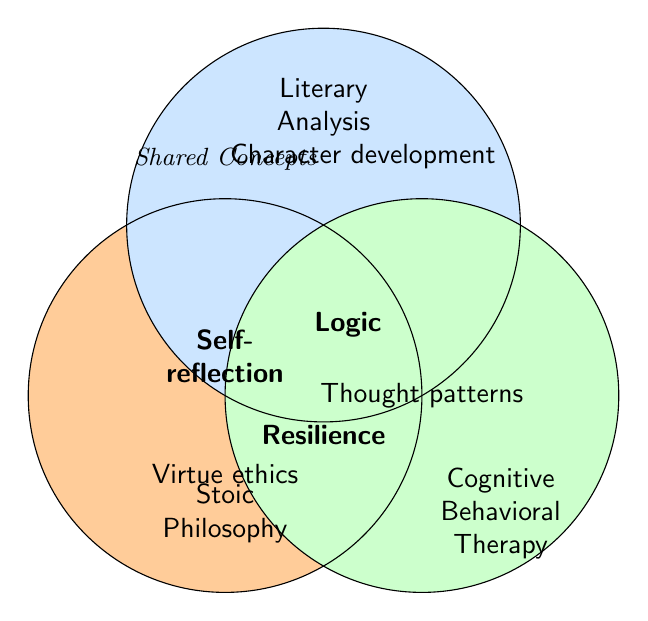What's the meaning of the text "Virtue ethics" placed within the Stoic Philosophy circle? "Virtue ethics" is a concept specific to Stoic Philosophy, which is why it is placed within that circle.
Answer: Stoic Philosophy concept Which concept is shared by all three fields: Stoic Philosophy, Literary Analysis, and Cognitive Behavioral Therapy? The concept that is shared by all three is located at the intersection of all three circles. "Self-reflection," "Logic," and "Resilience" are found in this intersection.
Answer: Self-reflection, Logic, Resilience What concept is represented in the overlap between Stoic Philosophy and Literary Analysis? By observing the areas where Stoic Philosophy and Literary Analysis circles overlap, "Logic" and "Self-reflection" appear in that shared space.
Answer: Logic, Self-reflection Identify a concept unique to Cognitive Behavioral Therapy. By looking at the area exclusively within the Cognitive Behavioral Therapy circle and not intersecting with other circles, "Thought patterns" and "Reframing perspectives" can be identified.
Answer: Thought patterns, Reframing perspectives In the Venn diagram, where would you find the concept of "Character development"? "Character development" is specific to Literary Analysis, so it is placed within that circle only.
Answer: Literary Analysis 